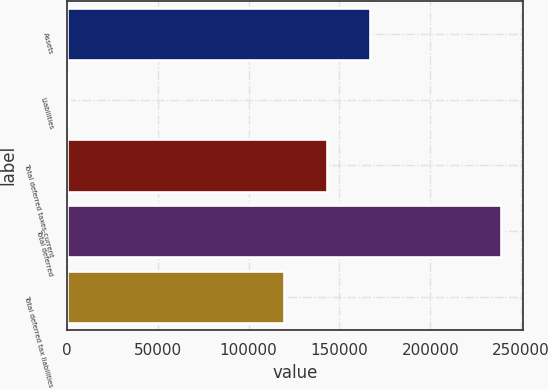<chart> <loc_0><loc_0><loc_500><loc_500><bar_chart><fcel>Assets<fcel>Liabilities<fcel>Total deferred taxes-current<fcel>Total deferred<fcel>Total deferred tax liabilities<nl><fcel>166836<fcel>1194<fcel>143040<fcel>239148<fcel>119245<nl></chart> 